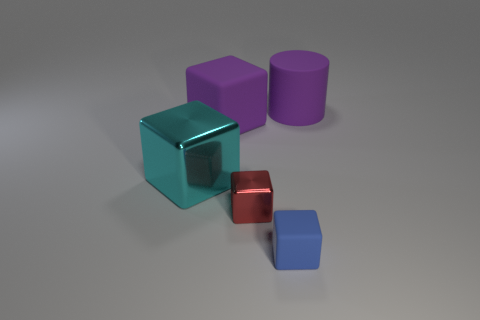Do the metallic cube in front of the big cyan metallic cube and the large rubber object on the left side of the purple rubber cylinder have the same color?
Offer a very short reply. No. Are there the same number of blue objects that are in front of the blue block and brown shiny cubes?
Offer a terse response. Yes. How many purple rubber cylinders are on the left side of the tiny blue matte object?
Provide a succinct answer. 0. What size is the red block?
Provide a short and direct response. Small. What color is the big object that is the same material as the large purple cylinder?
Your response must be concise. Purple. How many cyan metal cubes have the same size as the red metal block?
Provide a short and direct response. 0. Are the purple thing in front of the large matte cylinder and the cylinder made of the same material?
Ensure brevity in your answer.  Yes. Is the number of big purple blocks on the right side of the large rubber block less than the number of small cyan objects?
Your answer should be very brief. No. What shape is the big purple matte thing that is left of the small blue thing?
Ensure brevity in your answer.  Cube. There is a purple thing that is the same size as the purple block; what is its shape?
Give a very brief answer. Cylinder. 